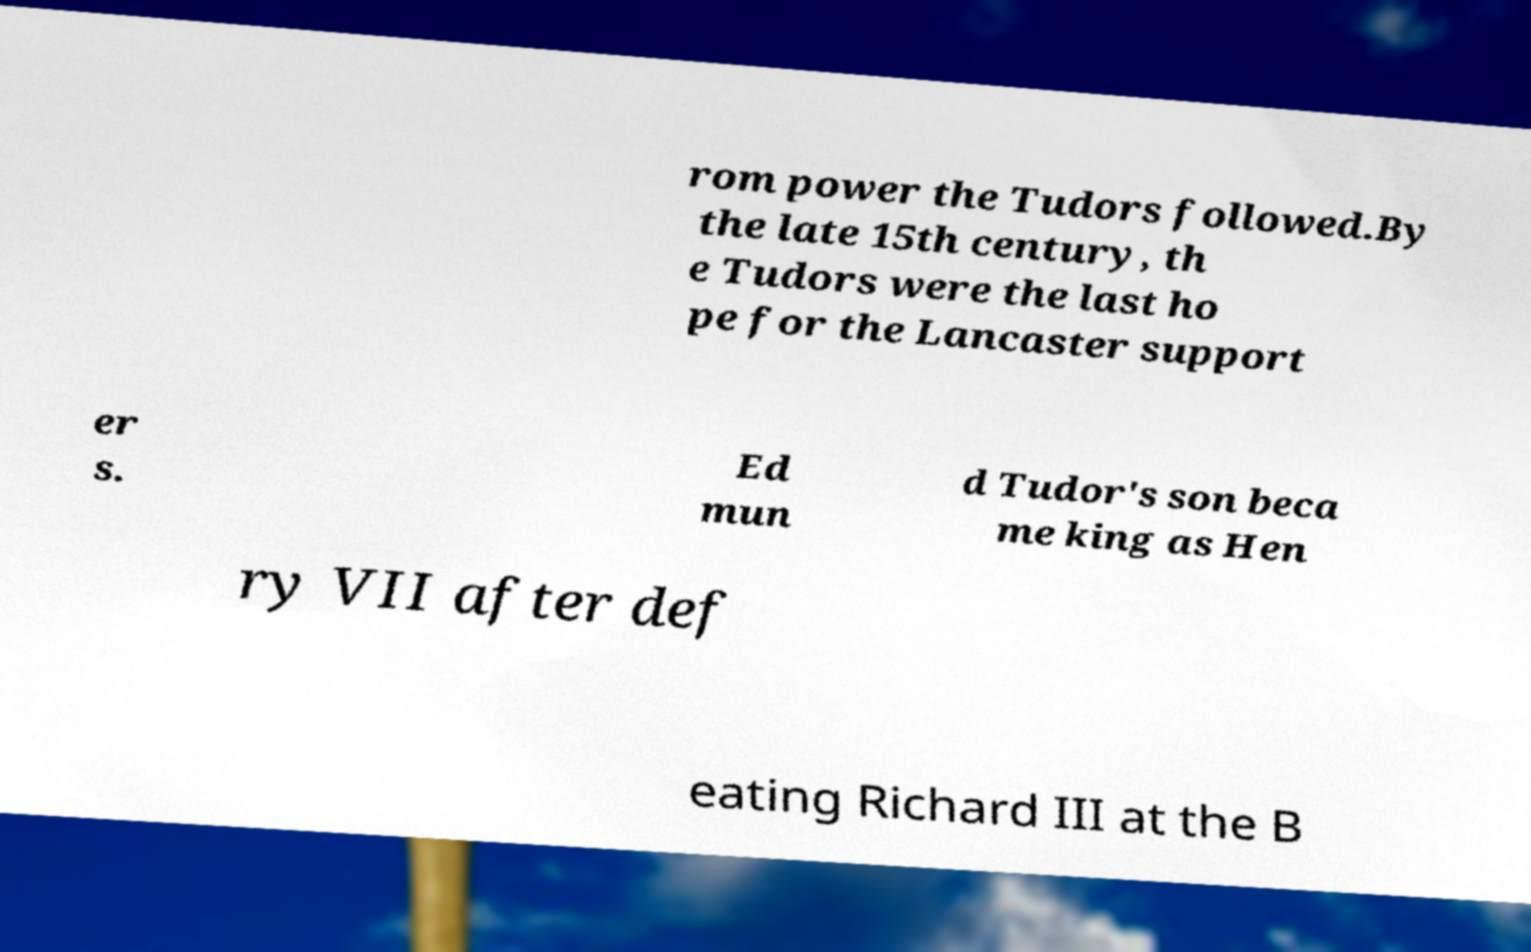Please read and relay the text visible in this image. What does it say? rom power the Tudors followed.By the late 15th century, th e Tudors were the last ho pe for the Lancaster support er s. Ed mun d Tudor's son beca me king as Hen ry VII after def eating Richard III at the B 